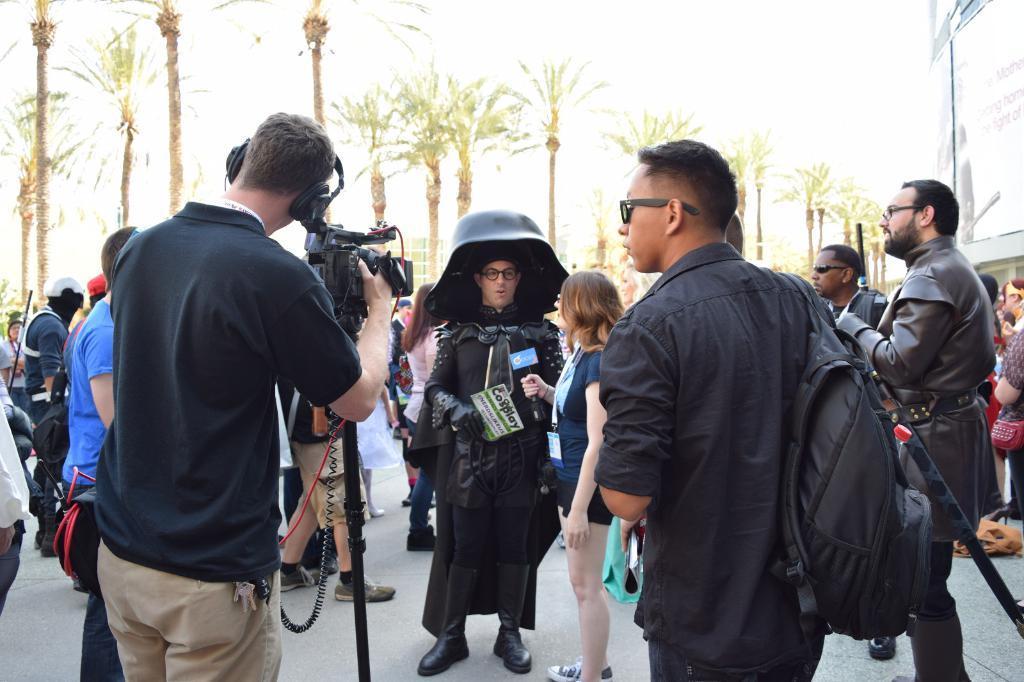Can you describe this image briefly? In this picture we can see the man wearing black costume, standing in the front and giving the interview which is taken by the girl. In the front left side there man wearing black color t-shirt is shooting with the camera. In the background there are many coconut trees. 